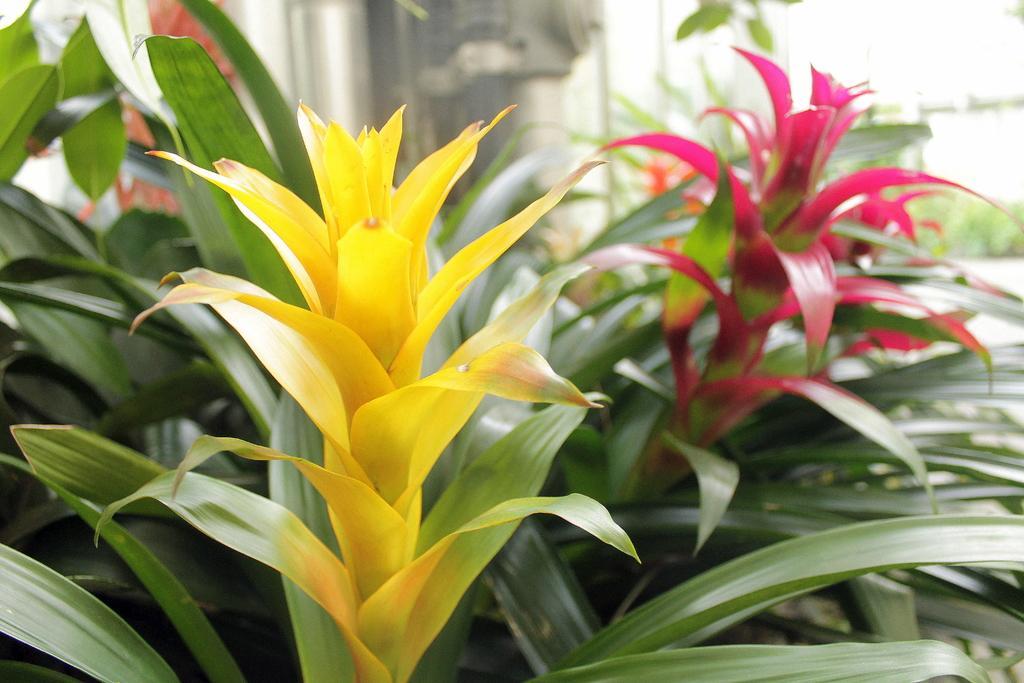Please provide a concise description of this image. In this image, we can see few plants with flowers. Background there is a blur view. 